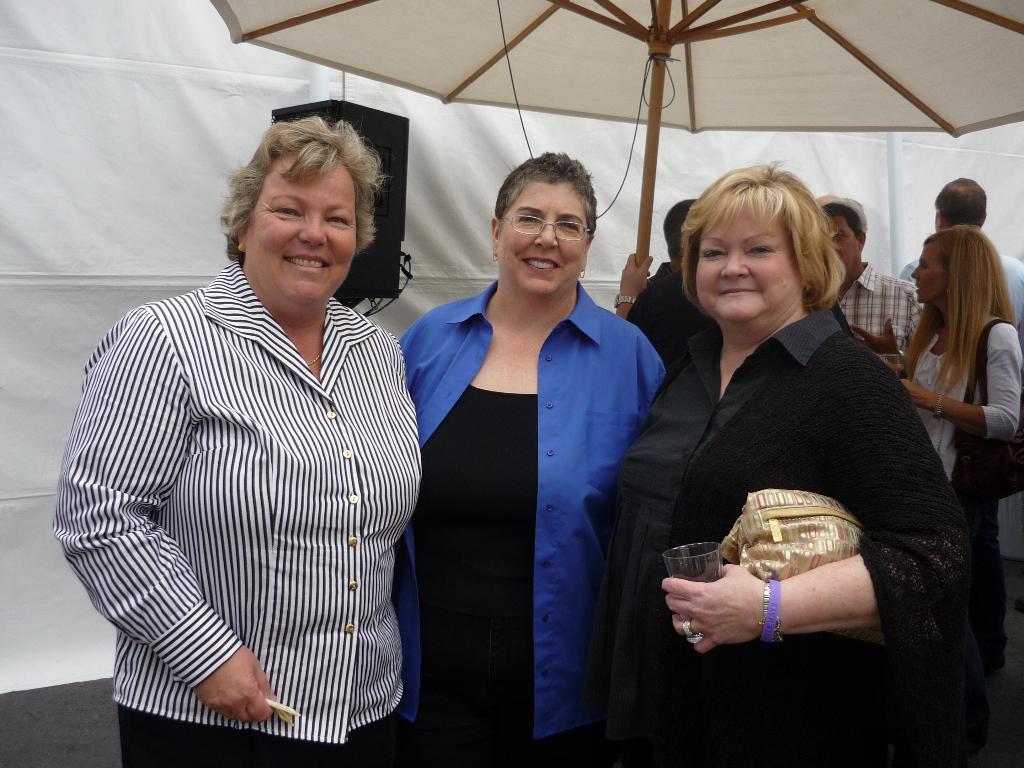Could you give a brief overview of what you see in this image? In this picture I can see there are three women standing and they are smiling. The woman on top right is holding a glass and a handbag. There is a umbrella in the backdrop and there is a speaker and a white surface. 